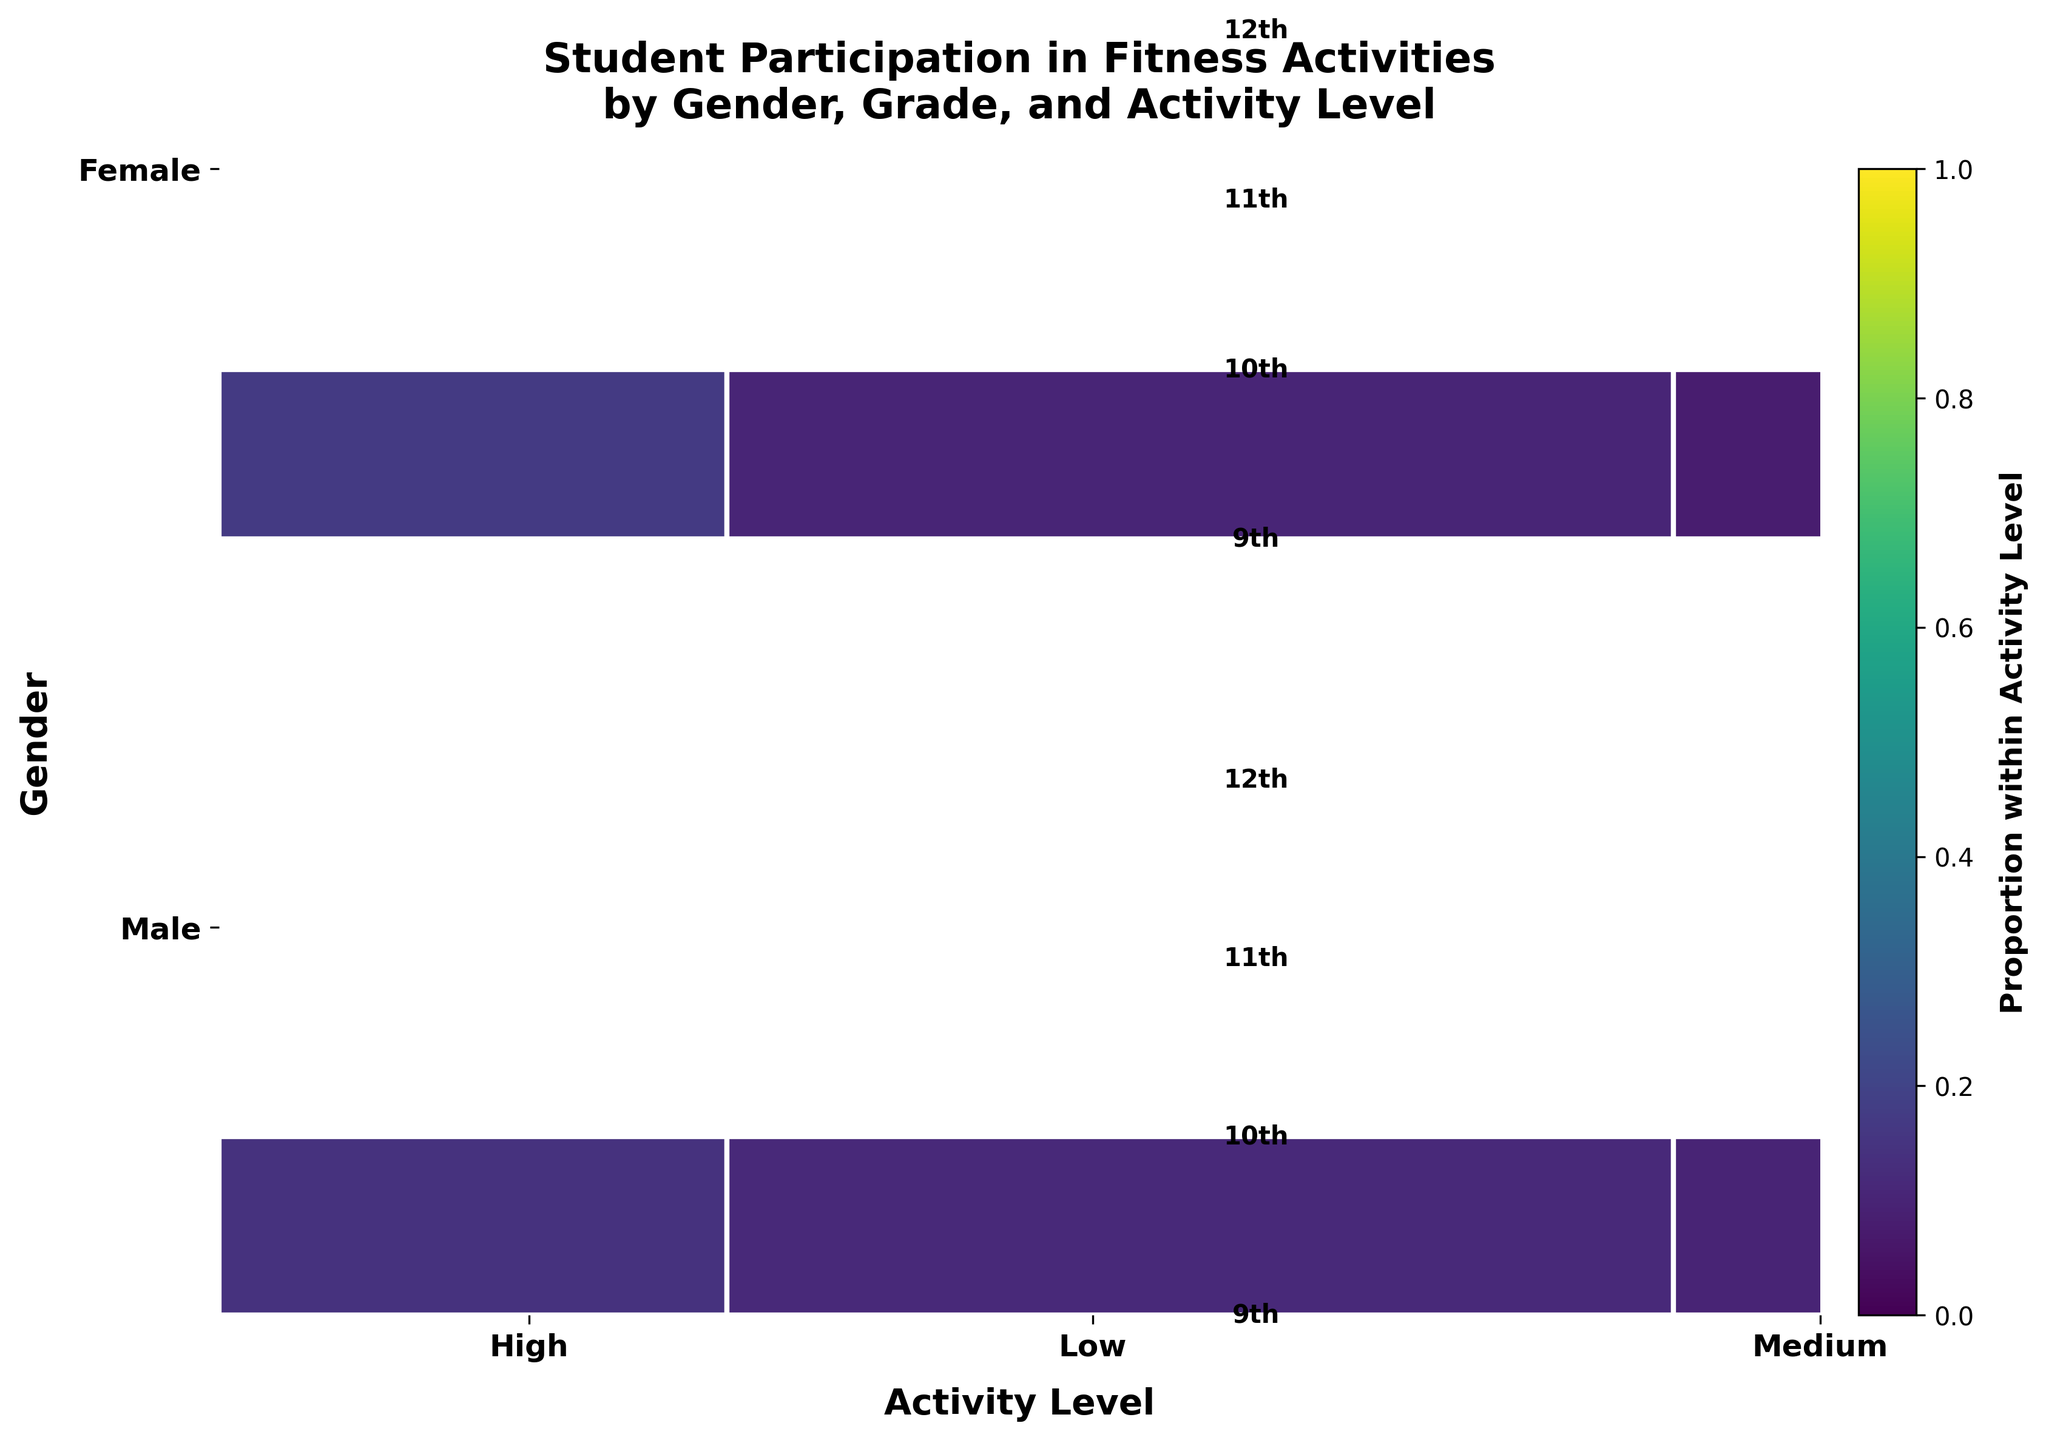What's the title of the plot? Look at the top of the plot where the title is usually displayed.
Answer: Student Participation in Fitness Activities by Gender, Grade, and Activity Level What are the categories of the X-axis? Identify the descriptions displayed along the X-axis of the plot.
Answer: Low, Medium, High What are the categories of the Y-axis? Identify the descriptions displayed along the Y-axis of the plot.
Answer: Male, Female Which gender has a higher participation at high activity level in 12th grade? Compare the size of the bars representing "High" activity level for males and females in the 12th grade section.
Answer: Female Comparing 10th grade, which gender shows higher participation in medium activity? Examine the section of the plot corresponding to 10th grade and compare the height of the bars labeled "Medium" activity for each gender.
Answer: Male Between 9th and 11th grades, which grade shows a higher total participation for low activity among females? Locate the sections for 9th and 11th grades under the "Female" category and compare the height of the bars labeled "Low" activity.
Answer: 9th Which activity level shows the highest aggregate participation for males across all grades? Sum the heights of bars across all grades for the male category for each activity level and determine the highest.
Answer: Medium What is the proportion difference in low activity levels between males and females in 10th grade? Calculate the proportion of low activity participation for both genders in 10th grade and find the difference.
Answer: 2 In 11th grade, which gender has the highest variation in activity levels? Examine the 11th grade section for both genders and compare the differences in bar heights across the activity levels.
Answer: Male 